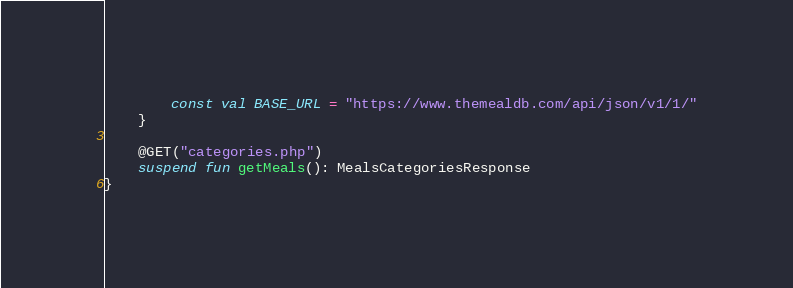<code> <loc_0><loc_0><loc_500><loc_500><_Kotlin_>        const val BASE_URL = "https://www.themealdb.com/api/json/v1/1/"
    }

    @GET("categories.php")
    suspend fun getMeals(): MealsCategoriesResponse
}</code> 